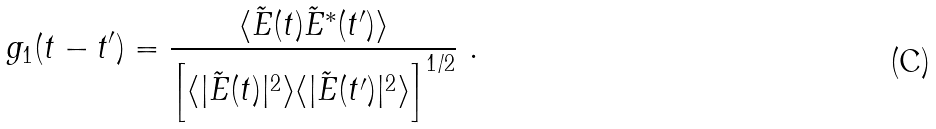Convert formula to latex. <formula><loc_0><loc_0><loc_500><loc_500>g _ { 1 } ( t - t ^ { \prime } ) = \frac { \langle \tilde { E } ( t ) \tilde { E } ^ { * } ( t ^ { \prime } ) \rangle } { \left [ \langle | \tilde { E } ( t ) | ^ { 2 } \rangle \langle | \tilde { E } ( t ^ { \prime } ) | ^ { 2 } \rangle \right ] ^ { 1 / 2 } } \ .</formula> 